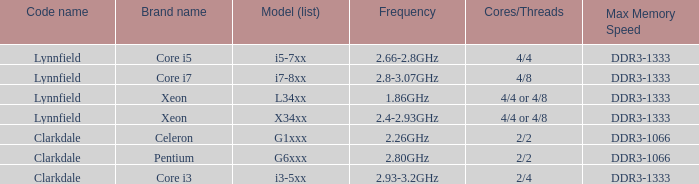What brand is model I7-8xx? Core i7. 